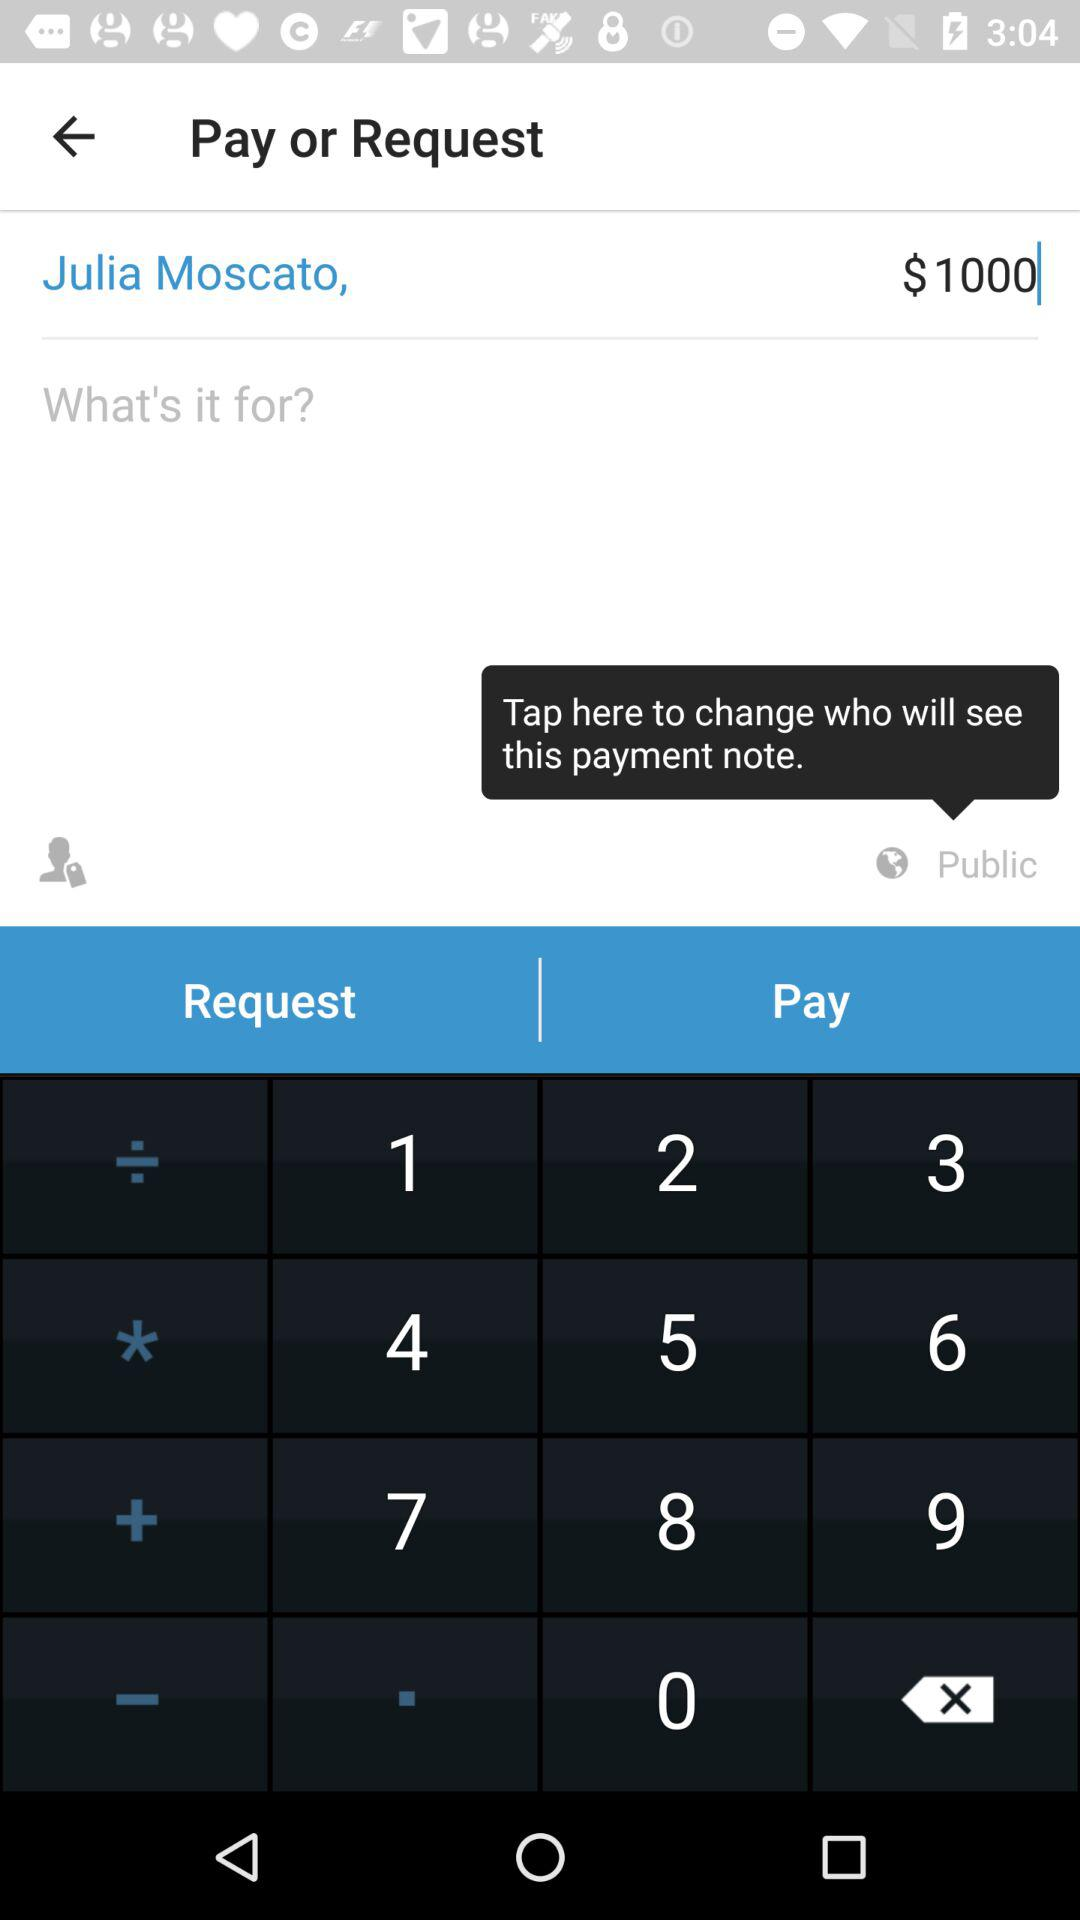How many dollars are entered? The number of entered dollars is 1000. 